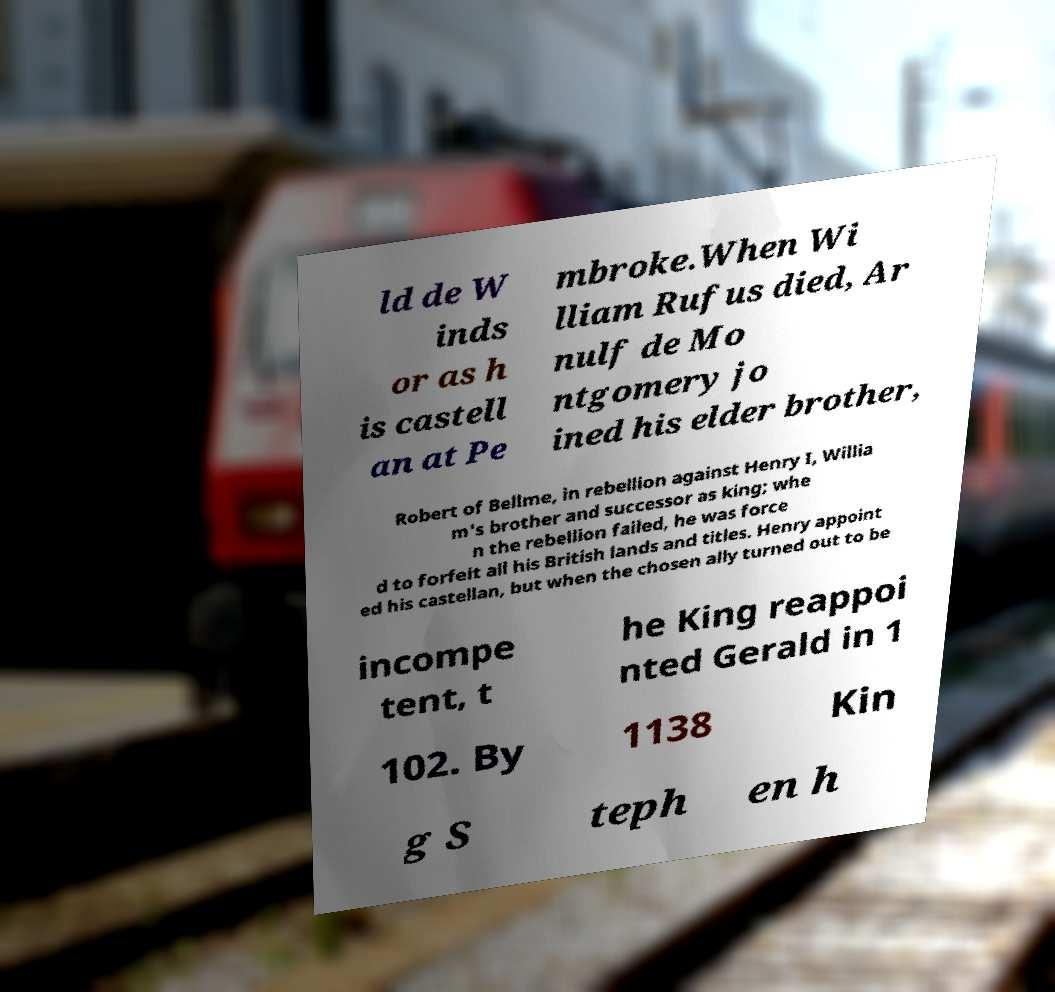There's text embedded in this image that I need extracted. Can you transcribe it verbatim? ld de W inds or as h is castell an at Pe mbroke.When Wi lliam Rufus died, Ar nulf de Mo ntgomery jo ined his elder brother, Robert of Bellme, in rebellion against Henry I, Willia m's brother and successor as king; whe n the rebellion failed, he was force d to forfeit all his British lands and titles. Henry appoint ed his castellan, but when the chosen ally turned out to be incompe tent, t he King reappoi nted Gerald in 1 102. By 1138 Kin g S teph en h 